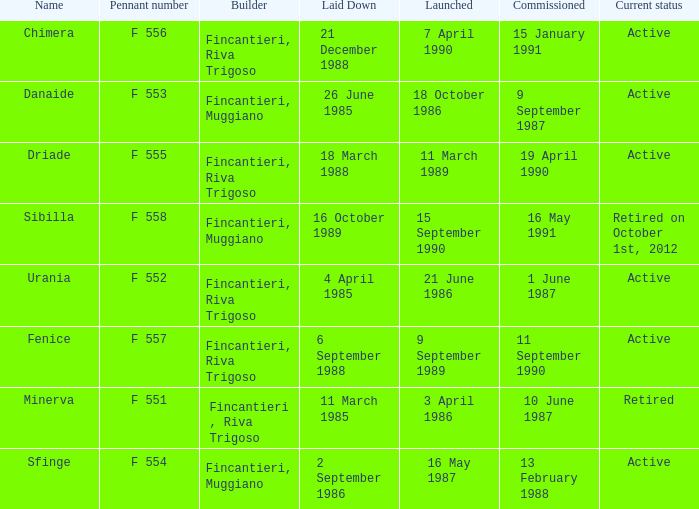What builder is now retired F 551. 